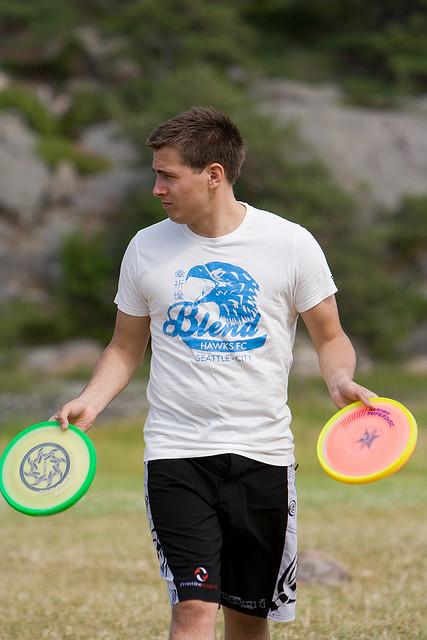How many frisbees is he holding?
Be succinct. 2. What color are the man's pants?
Give a very brief answer. Black. What word is written on his T-Shirt?
Keep it brief. Blend. What sport is being played?
Concise answer only. Frisbee. What name is on the shirt?
Concise answer only. Blend. 